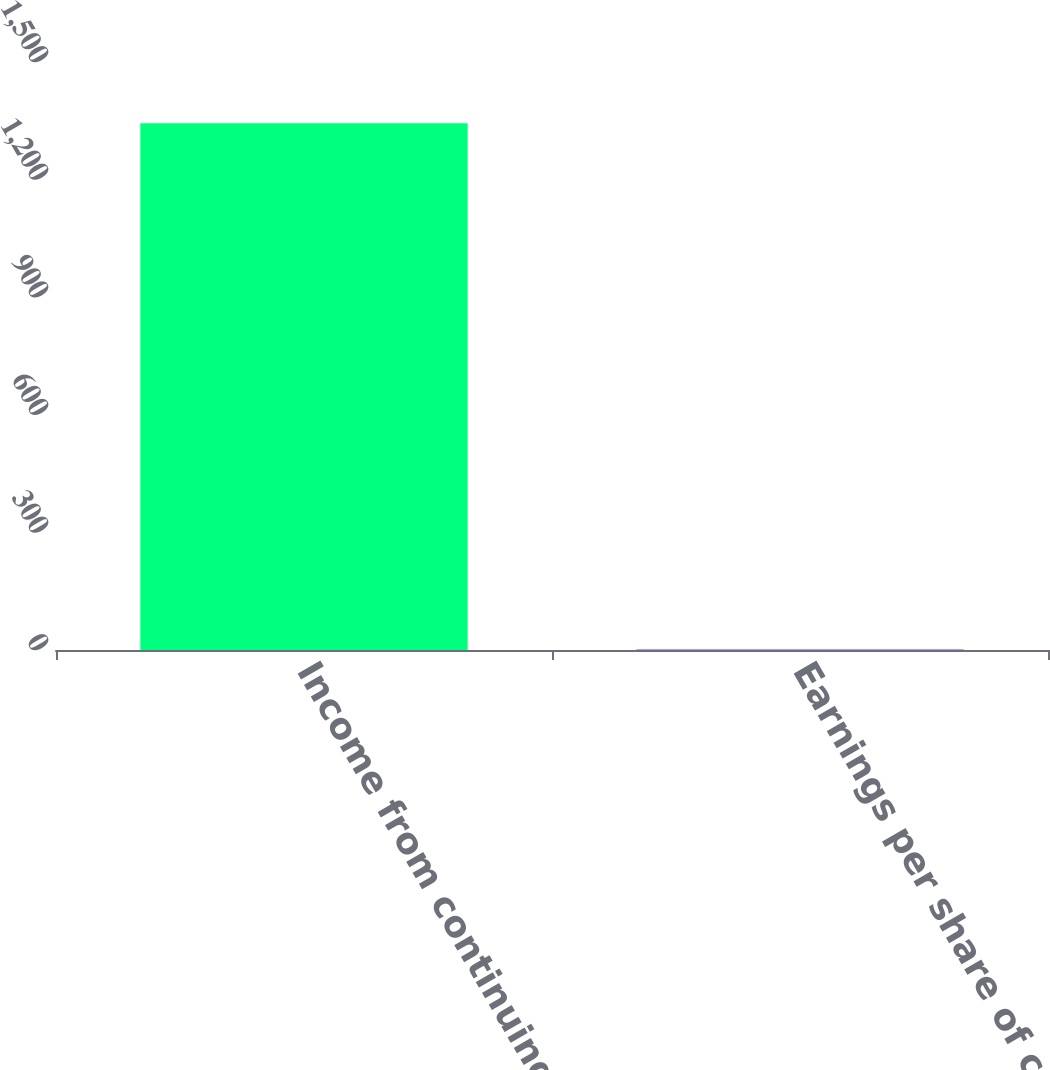Convert chart to OTSL. <chart><loc_0><loc_0><loc_500><loc_500><bar_chart><fcel>Income from continuing<fcel>Earnings per share of common<nl><fcel>1344<fcel>1.56<nl></chart> 